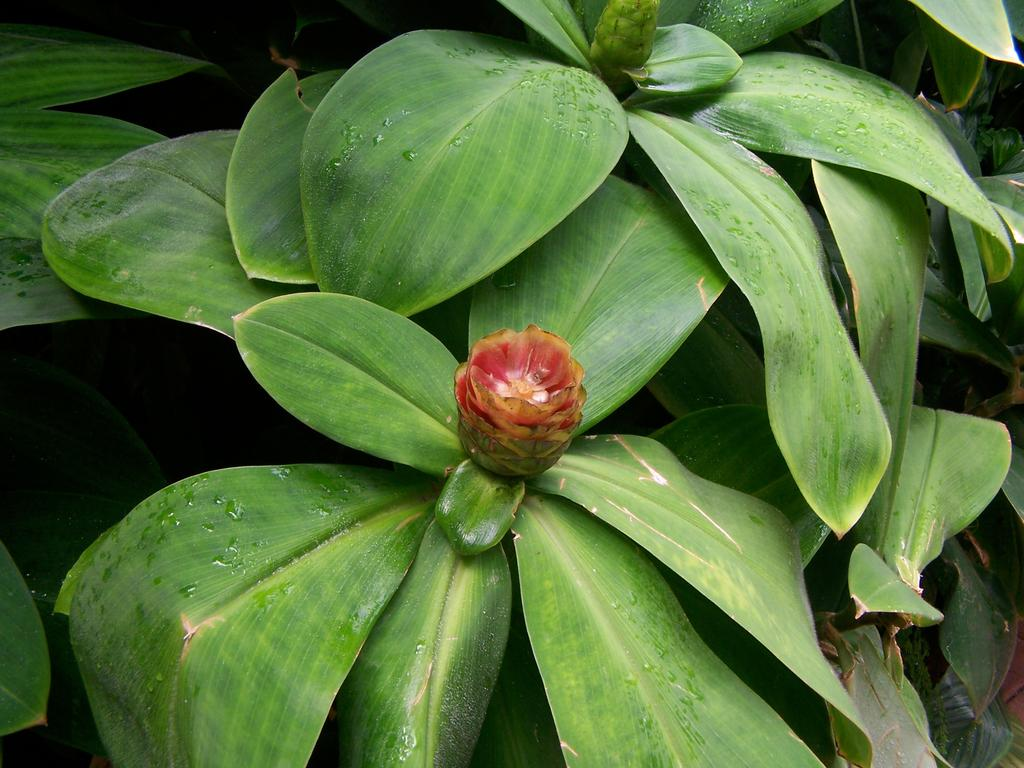What is the main subject of the image? The main subject of the image is a plant. What specific parts of the plant can be seen in the image? There are leaves and two small flowers visible in the image. What type of ship can be seen sailing in the background of the image? There is no ship present in the image; it is a zoomed-in view of a plant. 